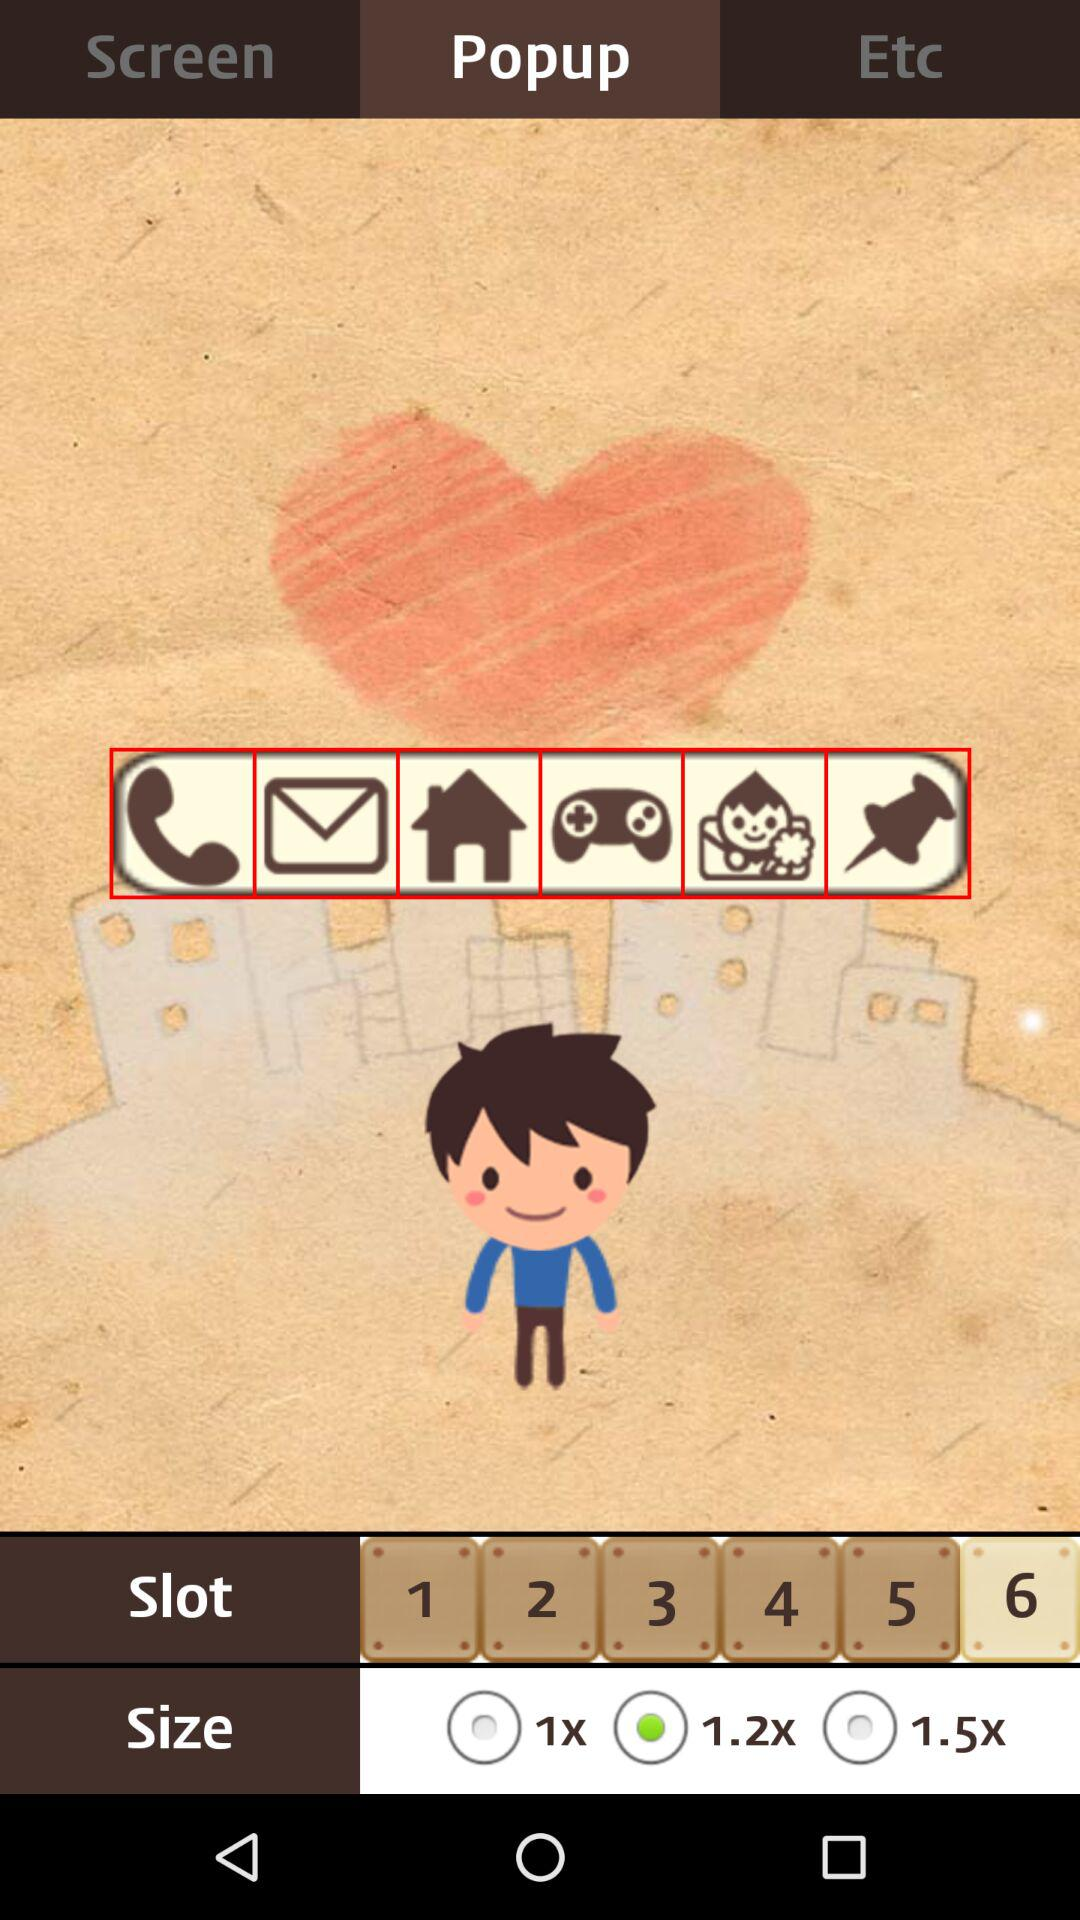Which is the chosen slot? The chosen slot is "6". 